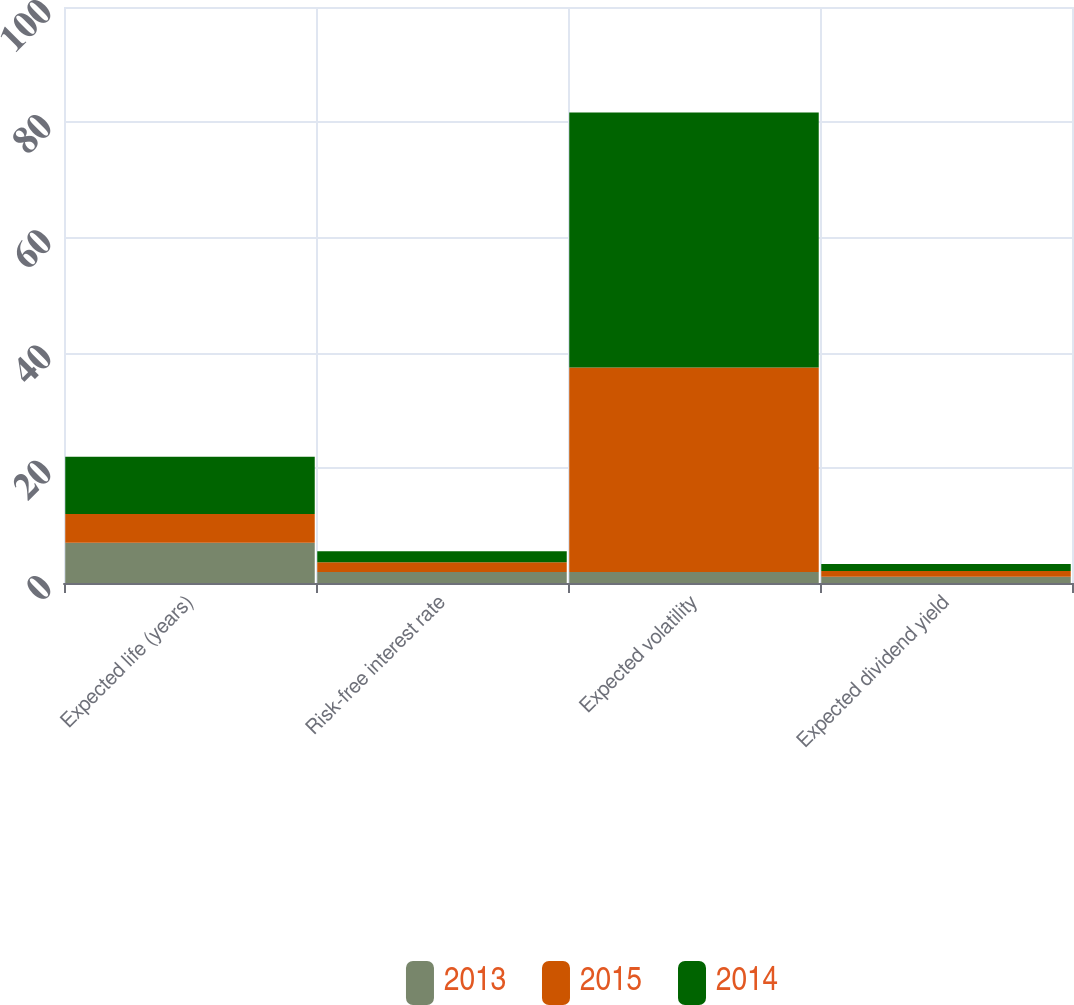Convert chart to OTSL. <chart><loc_0><loc_0><loc_500><loc_500><stacked_bar_chart><ecel><fcel>Expected life (years)<fcel>Risk-free interest rate<fcel>Expected volatility<fcel>Expected dividend yield<nl><fcel>2013<fcel>7<fcel>1.9<fcel>1.9<fcel>1.1<nl><fcel>2015<fcel>5<fcel>1.7<fcel>35.5<fcel>1<nl><fcel>2014<fcel>9.9<fcel>1.9<fcel>44.3<fcel>1.2<nl></chart> 